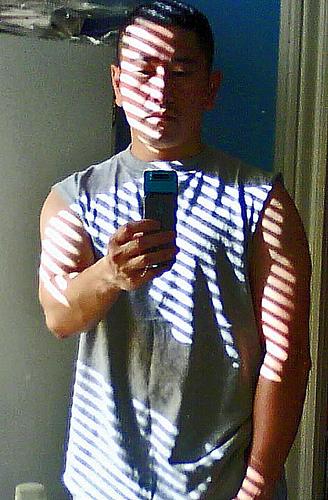The action depicted in this image is called taking a what?
Be succinct. Selfie. Are there shadows in this picture?
Keep it brief. Yes. Does this man have sleeves on his shirt?
Answer briefly. No. 